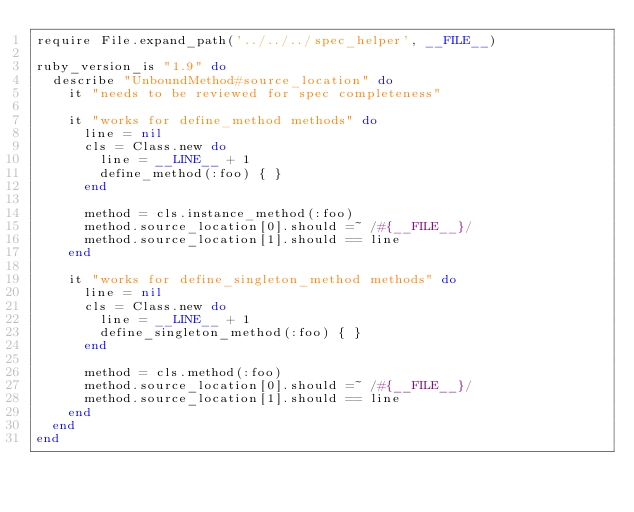Convert code to text. <code><loc_0><loc_0><loc_500><loc_500><_Ruby_>require File.expand_path('../../../spec_helper', __FILE__)

ruby_version_is "1.9" do
  describe "UnboundMethod#source_location" do
    it "needs to be reviewed for spec completeness"

    it "works for define_method methods" do
      line = nil
      cls = Class.new do
        line = __LINE__ + 1
        define_method(:foo) { }
      end

      method = cls.instance_method(:foo)
      method.source_location[0].should =~ /#{__FILE__}/
      method.source_location[1].should == line
    end

    it "works for define_singleton_method methods" do
      line = nil
      cls = Class.new do
        line = __LINE__ + 1
        define_singleton_method(:foo) { }
      end

      method = cls.method(:foo)
      method.source_location[0].should =~ /#{__FILE__}/
      method.source_location[1].should == line
    end
  end
end
</code> 